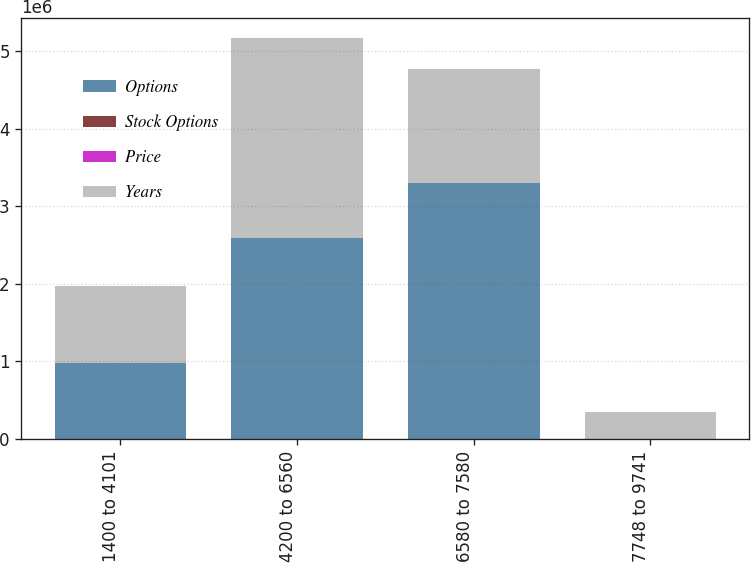Convert chart. <chart><loc_0><loc_0><loc_500><loc_500><stacked_bar_chart><ecel><fcel>1400 to 4101<fcel>4200 to 6560<fcel>6580 to 7580<fcel>7748 to 9741<nl><fcel>Options<fcel>983343<fcel>2.59027e+06<fcel>3.30206e+06<fcel>86.42<nl><fcel>Stock Options<fcel>23.7<fcel>45.83<fcel>70.89<fcel>86.42<nl><fcel>Price<fcel>1.4<fcel>4.3<fcel>6.5<fcel>8.5<nl><fcel>Years<fcel>983343<fcel>2.58427e+06<fcel>1.46779e+06<fcel>348370<nl></chart> 